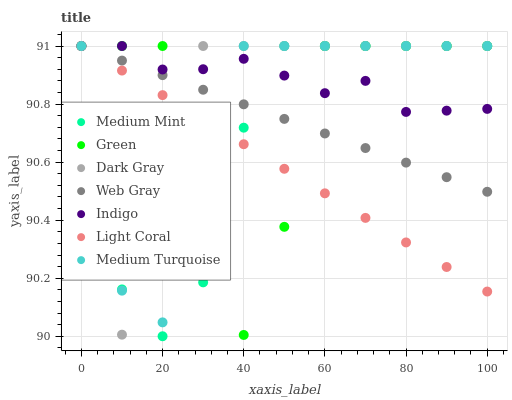Does Light Coral have the minimum area under the curve?
Answer yes or no. Yes. Does Indigo have the maximum area under the curve?
Answer yes or no. Yes. Does Web Gray have the minimum area under the curve?
Answer yes or no. No. Does Web Gray have the maximum area under the curve?
Answer yes or no. No. Is Light Coral the smoothest?
Answer yes or no. Yes. Is Green the roughest?
Answer yes or no. Yes. Is Web Gray the smoothest?
Answer yes or no. No. Is Web Gray the roughest?
Answer yes or no. No. Does Medium Mint have the lowest value?
Answer yes or no. Yes. Does Light Coral have the lowest value?
Answer yes or no. No. Does Medium Turquoise have the highest value?
Answer yes or no. Yes. Does Web Gray intersect Medium Turquoise?
Answer yes or no. Yes. Is Web Gray less than Medium Turquoise?
Answer yes or no. No. Is Web Gray greater than Medium Turquoise?
Answer yes or no. No. 